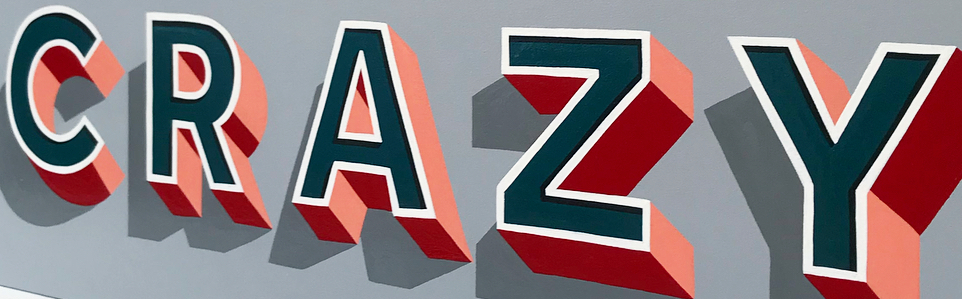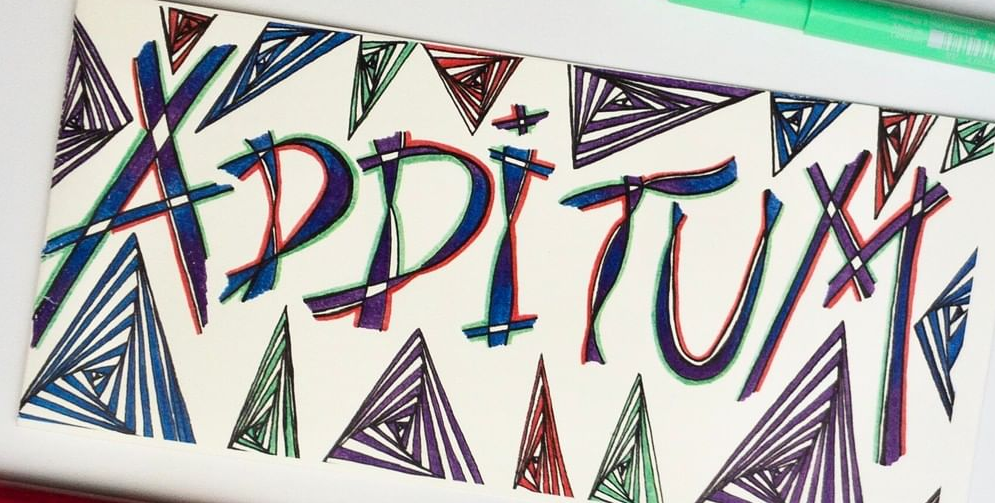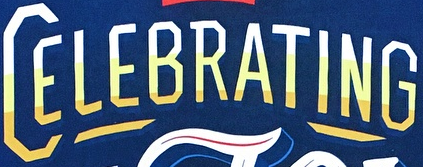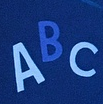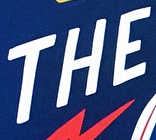What words can you see in these images in sequence, separated by a semicolon? CRAZY; ADDITUM; CELEBRATING; ABC; THE 